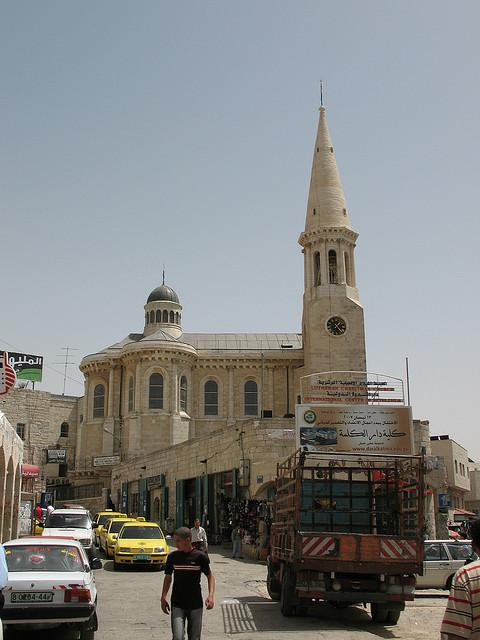What sound source can be found above the clock here? Please explain your reasoning. bell. The bell makes noise. 